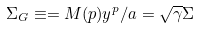Convert formula to latex. <formula><loc_0><loc_0><loc_500><loc_500>\Sigma _ { G } \equiv = M ( p ) y ^ { p } / a = \sqrt { \gamma } \Sigma</formula> 